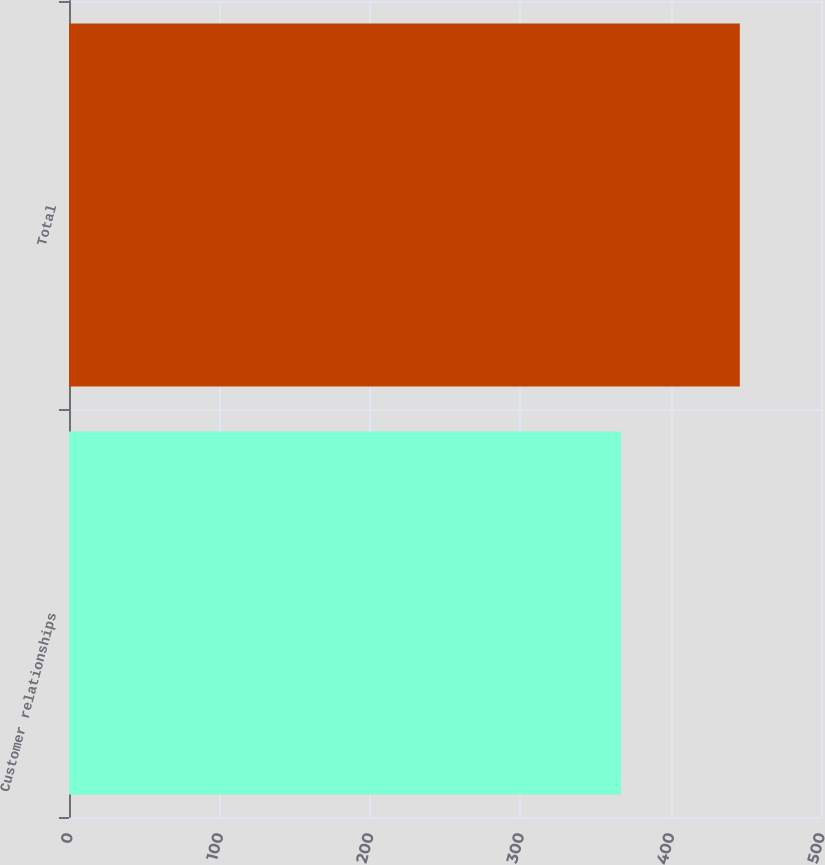Convert chart to OTSL. <chart><loc_0><loc_0><loc_500><loc_500><bar_chart><fcel>Customer relationships<fcel>Total<nl><fcel>367<fcel>446<nl></chart> 